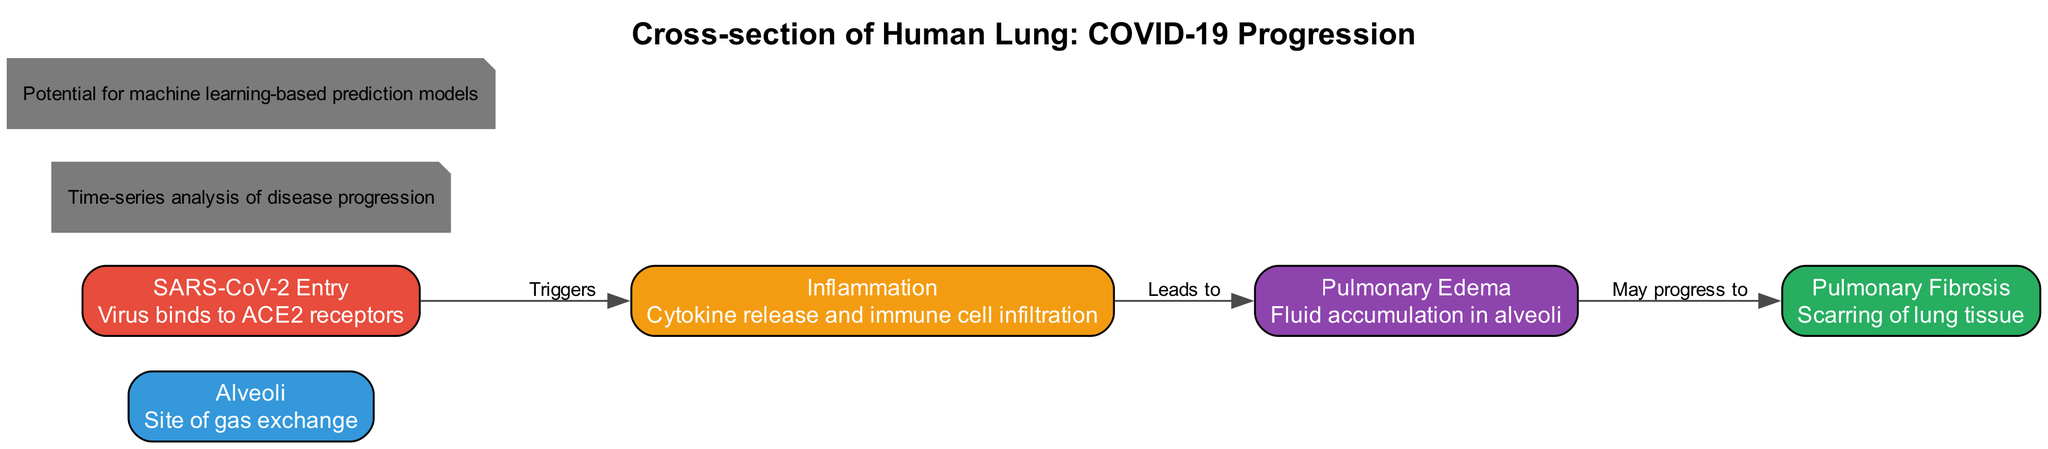What is the role of alveoli in the human lung? The alveoli are defined in the diagram as the site of gas exchange, indicating their crucial function in the respiratory process.
Answer: Site of gas exchange What triggers inflammation in COVID-19 progression? The diagram explicitly states that inflammation is triggered by the SARS-CoV-2 entry into the lung, which binds to ACE2 receptors.
Answer: SARS-CoV-2 Entry How many edges are in the diagram? By counting the connections between nodes in the edges section, there are three edges representing the progression from one condition to another.
Answer: 3 What condition follows inflammation in the progression of COVID-19? The diagram links inflammation to pulmonary edema, indicating that inflammation leads directly to this condition.
Answer: Pulmonary Edema What may occur after pulmonary edema in COVID-19 infection? The diagram indicates that pulmonary edema may progress to pulmonary fibrosis, representing a potential worsening of the condition.
Answer: Pulmonary Fibrosis Which node is associated with fluid accumulation? The diagram states that pulmonary edema is characterized by fluid accumulation in the alveoli, highlighting its role in this symptom.
Answer: Pulmonary Edema What is the relationship between virus entry and inflammation? According to the diagram, the relationship is that virus entry triggers inflammation, demonstrating the initial impact of SARS-CoV-2 infection.
Answer: Triggers Where does the diagram denote the potential for machine learning-based prediction models? The diagram specifically places the text indicating the potential for machine learning models on the right side, as an additional note.
Answer: Right What condition is indicated as a result of cytokine release and immune cell infiltration? The diagram indicates that this process leads to inflammation, showing its connection to the immune response in COVID-19.
Answer: Inflammation 